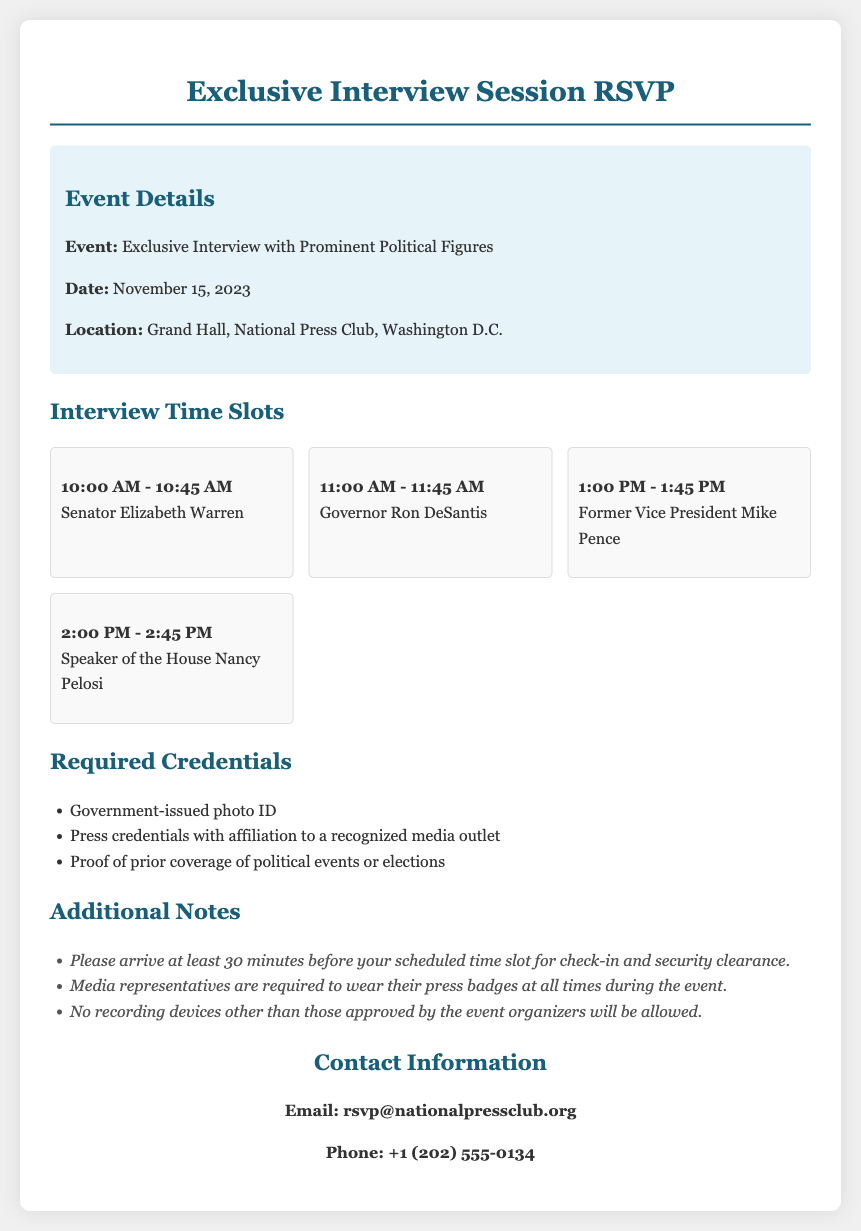What is the date of the event? The date of the event is clearly stated in the document, which is November 15, 2023.
Answer: November 15, 2023 Who is interviewing at 2:00 PM? The time slot for 2:00 PM includes the name of the political figure who will be interviewed, which is Speaker of the House Nancy Pelosi.
Answer: Nancy Pelosi What is required for entry? The document lists specific credentials needed for entry, including a government-issued photo ID and press credentials.
Answer: Government-issued photo ID How long is each interview slot? The document specifies that each interview slot lasts from the start time to the end time, which is a 45-minute duration for each slot.
Answer: 45 minutes What should media representatives wear during the event? The document states that media representatives are required to wear their press badges at all times during the event.
Answer: Press badges How many interview slots are available? The total number of time slots listed in the document indicates there are four available interview slots.
Answer: Four What is the location of the event? The location of the event is provided in the document, indicating it will take place at the Grand Hall, National Press Club, Washington D.C.
Answer: Grand Hall, National Press Club, Washington D.C What should attendees do before their interview time? The document suggests that attendees should arrive at least 30 minutes before their scheduled time slot for check-in and security clearance.
Answer: Arrive at least 30 minutes early What type of items are not allowed? The document mentions that no recording devices other than those approved by the event organizers will be allowed.
Answer: Recording devices 